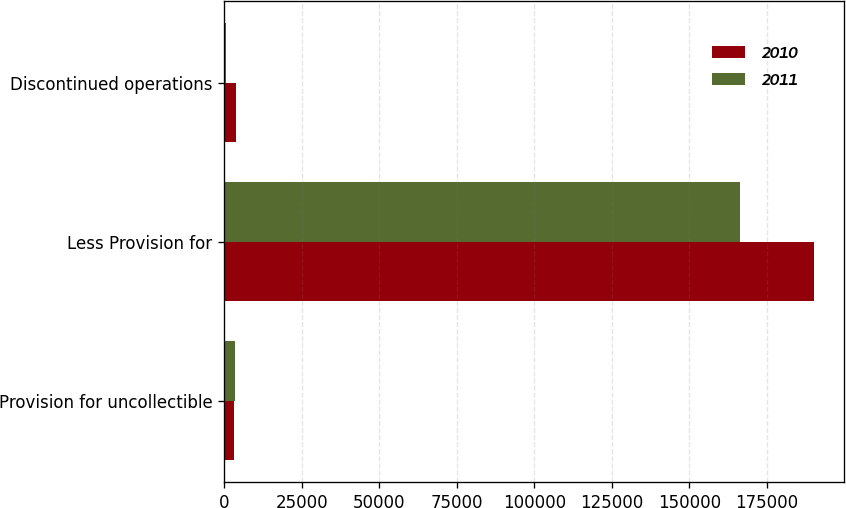<chart> <loc_0><loc_0><loc_500><loc_500><stacked_bar_chart><ecel><fcel>Provision for uncollectible<fcel>Less Provision for<fcel>Discontinued operations<nl><fcel>2010<fcel>3309<fcel>190234<fcel>4022<nl><fcel>2011<fcel>3566<fcel>166301<fcel>785<nl></chart> 